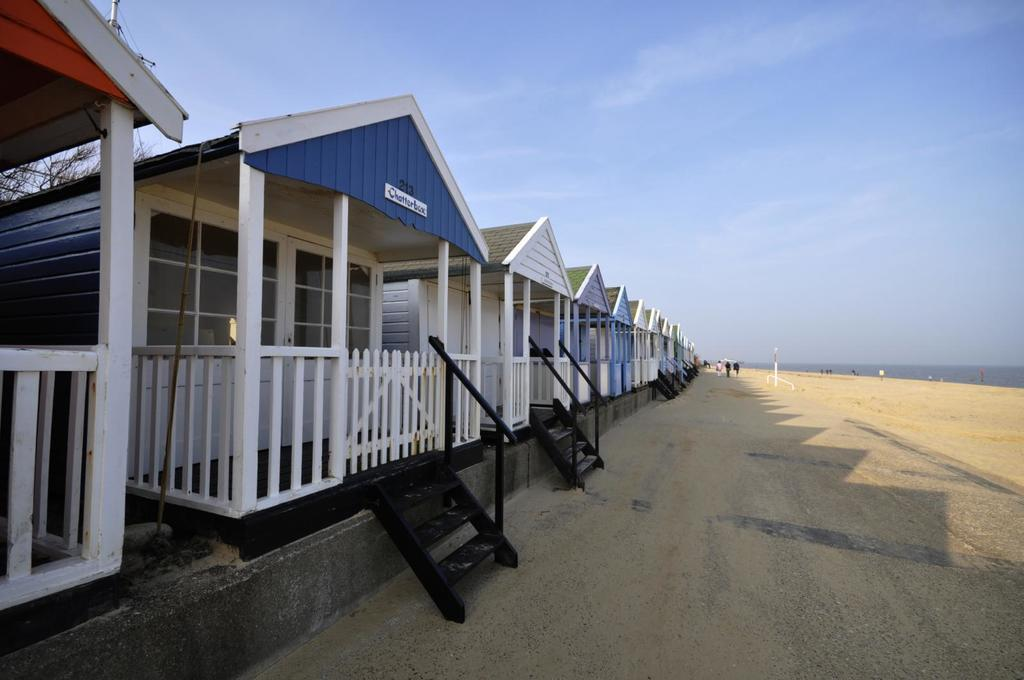What type of structures are present in the image? There are houses with name boards in the image. Are there any architectural features visible in the image? Yes, there are staircases in the image. Can you describe the people in the image? There is a group of people standing in the image. What type of terrain is visible in the image? Sand is visible in the image, along with water. What natural element is present in the image? There is a tree in the image. What part of the natural environment is visible in the image? The sky is visible in the image. What type of lettuce is being served at the playground in the image? There is no lettuce or playground present in the image. 